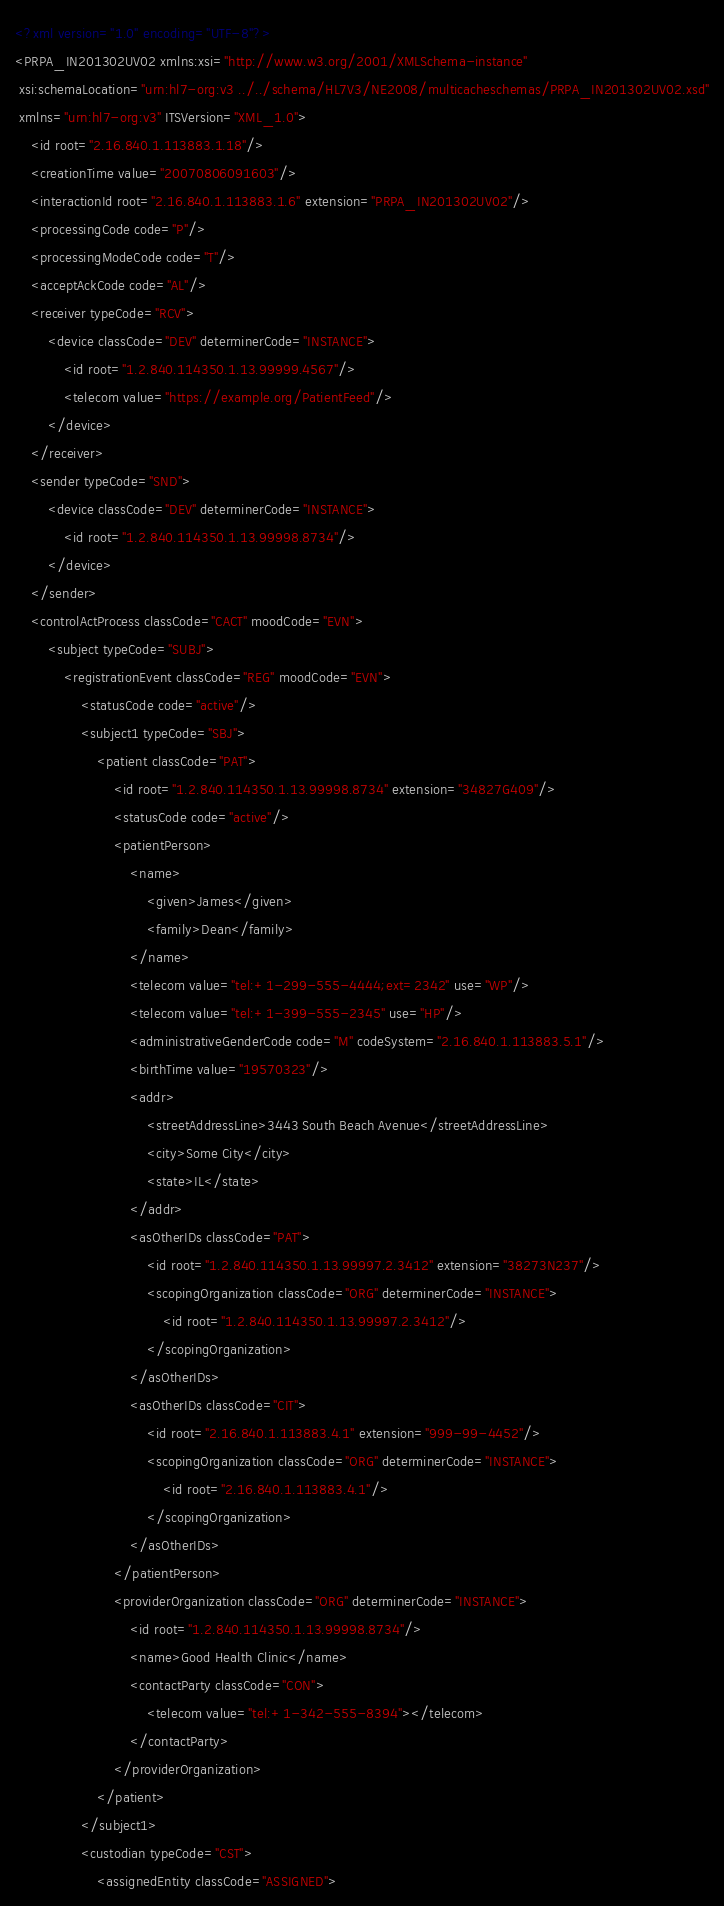<code> <loc_0><loc_0><loc_500><loc_500><_XML_><?xml version="1.0" encoding="UTF-8"?>
<PRPA_IN201302UV02 xmlns:xsi="http://www.w3.org/2001/XMLSchema-instance"
 xsi:schemaLocation="urn:hl7-org:v3 ../../schema/HL7V3/NE2008/multicacheschemas/PRPA_IN201302UV02.xsd"
 xmlns="urn:hl7-org:v3" ITSVersion="XML_1.0">
    <id root="2.16.840.1.113883.1.18"/>
    <creationTime value="20070806091603"/>
    <interactionId root="2.16.840.1.113883.1.6" extension="PRPA_IN201302UV02"/>
    <processingCode code="P"/>
    <processingModeCode code="T"/>
    <acceptAckCode code="AL"/>
    <receiver typeCode="RCV">
        <device classCode="DEV" determinerCode="INSTANCE">
            <id root="1.2.840.114350.1.13.99999.4567"/>
            <telecom value="https://example.org/PatientFeed"/>
        </device>
    </receiver>
    <sender typeCode="SND">
        <device classCode="DEV" determinerCode="INSTANCE">
            <id root="1.2.840.114350.1.13.99998.8734"/>
        </device>
    </sender>
    <controlActProcess classCode="CACT" moodCode="EVN">
        <subject typeCode="SUBJ">
            <registrationEvent classCode="REG" moodCode="EVN">
                <statusCode code="active"/>
                <subject1 typeCode="SBJ">
                    <patient classCode="PAT">
                        <id root="1.2.840.114350.1.13.99998.8734" extension="34827G409"/>
                        <statusCode code="active"/>
                        <patientPerson>
                            <name>
                                <given>James</given>
                                <family>Dean</family>
                            </name>
                            <telecom value="tel:+1-299-555-4444;ext=2342" use="WP"/>
                            <telecom value="tel:+1-399-555-2345" use="HP"/>
                            <administrativeGenderCode code="M" codeSystem="2.16.840.1.113883.5.1"/>
                            <birthTime value="19570323"/>
                            <addr>
                                <streetAddressLine>3443 South Beach Avenue</streetAddressLine>
                                <city>Some City</city>
                                <state>IL</state>
                            </addr>
                            <asOtherIDs classCode="PAT">
                                <id root="1.2.840.114350.1.13.99997.2.3412" extension="38273N237"/>
                                <scopingOrganization classCode="ORG" determinerCode="INSTANCE">
                                    <id root="1.2.840.114350.1.13.99997.2.3412"/>
                                </scopingOrganization>
                            </asOtherIDs>
                            <asOtherIDs classCode="CIT">
                                <id root="2.16.840.1.113883.4.1" extension="999-99-4452"/>
                                <scopingOrganization classCode="ORG" determinerCode="INSTANCE">
                                    <id root="2.16.840.1.113883.4.1"/>
                                </scopingOrganization>
                            </asOtherIDs>
                        </patientPerson>
                        <providerOrganization classCode="ORG" determinerCode="INSTANCE">
                            <id root="1.2.840.114350.1.13.99998.8734"/>
                            <name>Good Health Clinic</name>
                            <contactParty classCode="CON">
                                <telecom value="tel:+1-342-555-8394"></telecom>
                            </contactParty>
                        </providerOrganization>
                    </patient>
                </subject1>
                <custodian typeCode="CST">
                    <assignedEntity classCode="ASSIGNED"></code> 